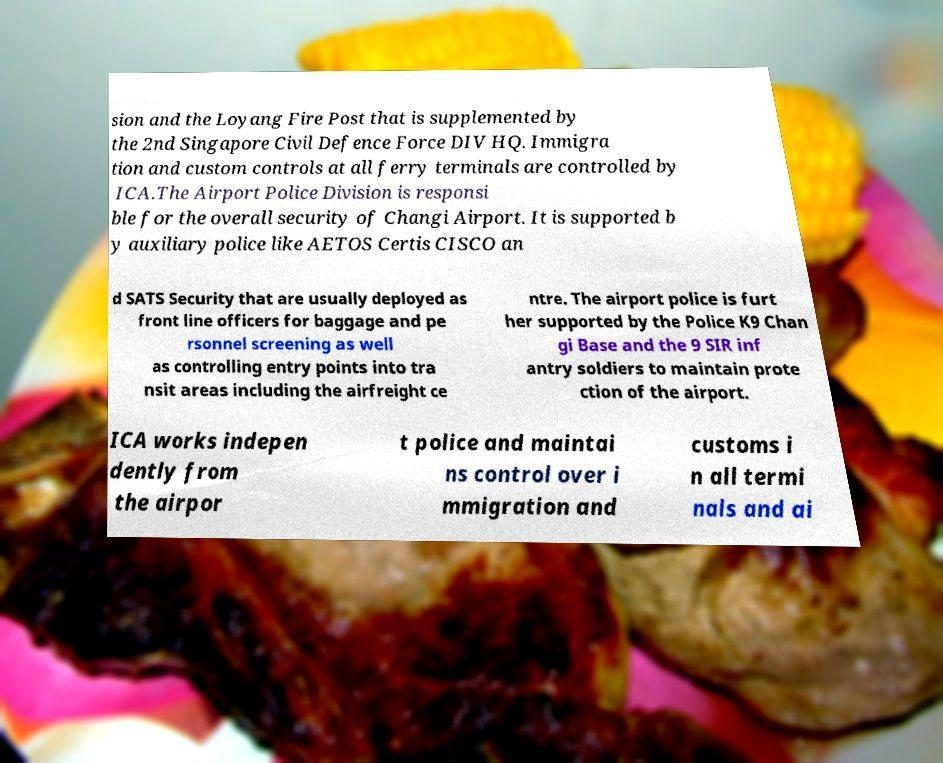Can you accurately transcribe the text from the provided image for me? sion and the Loyang Fire Post that is supplemented by the 2nd Singapore Civil Defence Force DIV HQ. Immigra tion and custom controls at all ferry terminals are controlled by ICA.The Airport Police Division is responsi ble for the overall security of Changi Airport. It is supported b y auxiliary police like AETOS Certis CISCO an d SATS Security that are usually deployed as front line officers for baggage and pe rsonnel screening as well as controlling entry points into tra nsit areas including the airfreight ce ntre. The airport police is furt her supported by the Police K9 Chan gi Base and the 9 SIR inf antry soldiers to maintain prote ction of the airport. ICA works indepen dently from the airpor t police and maintai ns control over i mmigration and customs i n all termi nals and ai 